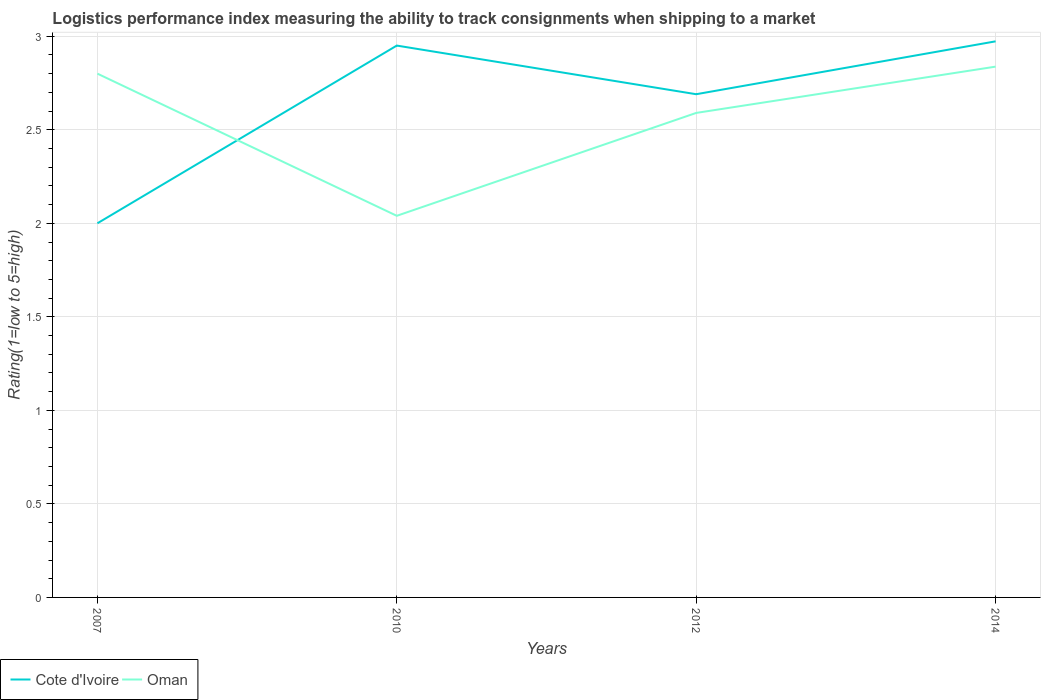Does the line corresponding to Cote d'Ivoire intersect with the line corresponding to Oman?
Make the answer very short. Yes. Is the number of lines equal to the number of legend labels?
Make the answer very short. Yes. In which year was the Logistic performance index in Oman maximum?
Offer a terse response. 2010. What is the total Logistic performance index in Oman in the graph?
Your answer should be very brief. -0.8. What is the difference between the highest and the second highest Logistic performance index in Oman?
Ensure brevity in your answer.  0.8. How many years are there in the graph?
Offer a very short reply. 4. Does the graph contain any zero values?
Provide a succinct answer. No. How many legend labels are there?
Offer a terse response. 2. What is the title of the graph?
Offer a terse response. Logistics performance index measuring the ability to track consignments when shipping to a market. What is the label or title of the X-axis?
Ensure brevity in your answer.  Years. What is the label or title of the Y-axis?
Your answer should be compact. Rating(1=low to 5=high). What is the Rating(1=low to 5=high) of Cote d'Ivoire in 2007?
Provide a short and direct response. 2. What is the Rating(1=low to 5=high) in Cote d'Ivoire in 2010?
Offer a very short reply. 2.95. What is the Rating(1=low to 5=high) of Oman in 2010?
Keep it short and to the point. 2.04. What is the Rating(1=low to 5=high) of Cote d'Ivoire in 2012?
Your answer should be compact. 2.69. What is the Rating(1=low to 5=high) in Oman in 2012?
Provide a short and direct response. 2.59. What is the Rating(1=low to 5=high) of Cote d'Ivoire in 2014?
Give a very brief answer. 2.97. What is the Rating(1=low to 5=high) of Oman in 2014?
Offer a very short reply. 2.84. Across all years, what is the maximum Rating(1=low to 5=high) of Cote d'Ivoire?
Your answer should be compact. 2.97. Across all years, what is the maximum Rating(1=low to 5=high) in Oman?
Offer a terse response. 2.84. Across all years, what is the minimum Rating(1=low to 5=high) in Cote d'Ivoire?
Your answer should be very brief. 2. Across all years, what is the minimum Rating(1=low to 5=high) of Oman?
Your answer should be compact. 2.04. What is the total Rating(1=low to 5=high) of Cote d'Ivoire in the graph?
Keep it short and to the point. 10.61. What is the total Rating(1=low to 5=high) of Oman in the graph?
Your answer should be very brief. 10.27. What is the difference between the Rating(1=low to 5=high) of Cote d'Ivoire in 2007 and that in 2010?
Make the answer very short. -0.95. What is the difference between the Rating(1=low to 5=high) of Oman in 2007 and that in 2010?
Your answer should be very brief. 0.76. What is the difference between the Rating(1=low to 5=high) in Cote d'Ivoire in 2007 and that in 2012?
Keep it short and to the point. -0.69. What is the difference between the Rating(1=low to 5=high) in Oman in 2007 and that in 2012?
Keep it short and to the point. 0.21. What is the difference between the Rating(1=low to 5=high) in Cote d'Ivoire in 2007 and that in 2014?
Ensure brevity in your answer.  -0.97. What is the difference between the Rating(1=low to 5=high) of Oman in 2007 and that in 2014?
Provide a short and direct response. -0.04. What is the difference between the Rating(1=low to 5=high) in Cote d'Ivoire in 2010 and that in 2012?
Give a very brief answer. 0.26. What is the difference between the Rating(1=low to 5=high) in Oman in 2010 and that in 2012?
Ensure brevity in your answer.  -0.55. What is the difference between the Rating(1=low to 5=high) of Cote d'Ivoire in 2010 and that in 2014?
Offer a very short reply. -0.02. What is the difference between the Rating(1=low to 5=high) of Oman in 2010 and that in 2014?
Offer a terse response. -0.8. What is the difference between the Rating(1=low to 5=high) in Cote d'Ivoire in 2012 and that in 2014?
Offer a terse response. -0.28. What is the difference between the Rating(1=low to 5=high) in Oman in 2012 and that in 2014?
Your answer should be very brief. -0.25. What is the difference between the Rating(1=low to 5=high) in Cote d'Ivoire in 2007 and the Rating(1=low to 5=high) in Oman in 2010?
Ensure brevity in your answer.  -0.04. What is the difference between the Rating(1=low to 5=high) in Cote d'Ivoire in 2007 and the Rating(1=low to 5=high) in Oman in 2012?
Ensure brevity in your answer.  -0.59. What is the difference between the Rating(1=low to 5=high) in Cote d'Ivoire in 2007 and the Rating(1=low to 5=high) in Oman in 2014?
Offer a terse response. -0.84. What is the difference between the Rating(1=low to 5=high) in Cote d'Ivoire in 2010 and the Rating(1=low to 5=high) in Oman in 2012?
Your answer should be very brief. 0.36. What is the difference between the Rating(1=low to 5=high) of Cote d'Ivoire in 2010 and the Rating(1=low to 5=high) of Oman in 2014?
Offer a very short reply. 0.11. What is the difference between the Rating(1=low to 5=high) in Cote d'Ivoire in 2012 and the Rating(1=low to 5=high) in Oman in 2014?
Provide a succinct answer. -0.15. What is the average Rating(1=low to 5=high) in Cote d'Ivoire per year?
Your answer should be compact. 2.65. What is the average Rating(1=low to 5=high) of Oman per year?
Give a very brief answer. 2.57. In the year 2007, what is the difference between the Rating(1=low to 5=high) in Cote d'Ivoire and Rating(1=low to 5=high) in Oman?
Offer a terse response. -0.8. In the year 2010, what is the difference between the Rating(1=low to 5=high) of Cote d'Ivoire and Rating(1=low to 5=high) of Oman?
Your response must be concise. 0.91. In the year 2012, what is the difference between the Rating(1=low to 5=high) in Cote d'Ivoire and Rating(1=low to 5=high) in Oman?
Your response must be concise. 0.1. In the year 2014, what is the difference between the Rating(1=low to 5=high) in Cote d'Ivoire and Rating(1=low to 5=high) in Oman?
Keep it short and to the point. 0.14. What is the ratio of the Rating(1=low to 5=high) in Cote d'Ivoire in 2007 to that in 2010?
Give a very brief answer. 0.68. What is the ratio of the Rating(1=low to 5=high) of Oman in 2007 to that in 2010?
Provide a succinct answer. 1.37. What is the ratio of the Rating(1=low to 5=high) in Cote d'Ivoire in 2007 to that in 2012?
Ensure brevity in your answer.  0.74. What is the ratio of the Rating(1=low to 5=high) of Oman in 2007 to that in 2012?
Provide a succinct answer. 1.08. What is the ratio of the Rating(1=low to 5=high) of Cote d'Ivoire in 2007 to that in 2014?
Ensure brevity in your answer.  0.67. What is the ratio of the Rating(1=low to 5=high) of Cote d'Ivoire in 2010 to that in 2012?
Provide a succinct answer. 1.1. What is the ratio of the Rating(1=low to 5=high) of Oman in 2010 to that in 2012?
Your answer should be very brief. 0.79. What is the ratio of the Rating(1=low to 5=high) of Cote d'Ivoire in 2010 to that in 2014?
Provide a short and direct response. 0.99. What is the ratio of the Rating(1=low to 5=high) in Oman in 2010 to that in 2014?
Your answer should be very brief. 0.72. What is the ratio of the Rating(1=low to 5=high) in Cote d'Ivoire in 2012 to that in 2014?
Ensure brevity in your answer.  0.9. What is the ratio of the Rating(1=low to 5=high) in Oman in 2012 to that in 2014?
Your answer should be compact. 0.91. What is the difference between the highest and the second highest Rating(1=low to 5=high) in Cote d'Ivoire?
Ensure brevity in your answer.  0.02. What is the difference between the highest and the second highest Rating(1=low to 5=high) in Oman?
Provide a succinct answer. 0.04. What is the difference between the highest and the lowest Rating(1=low to 5=high) of Cote d'Ivoire?
Offer a terse response. 0.97. What is the difference between the highest and the lowest Rating(1=low to 5=high) of Oman?
Your response must be concise. 0.8. 